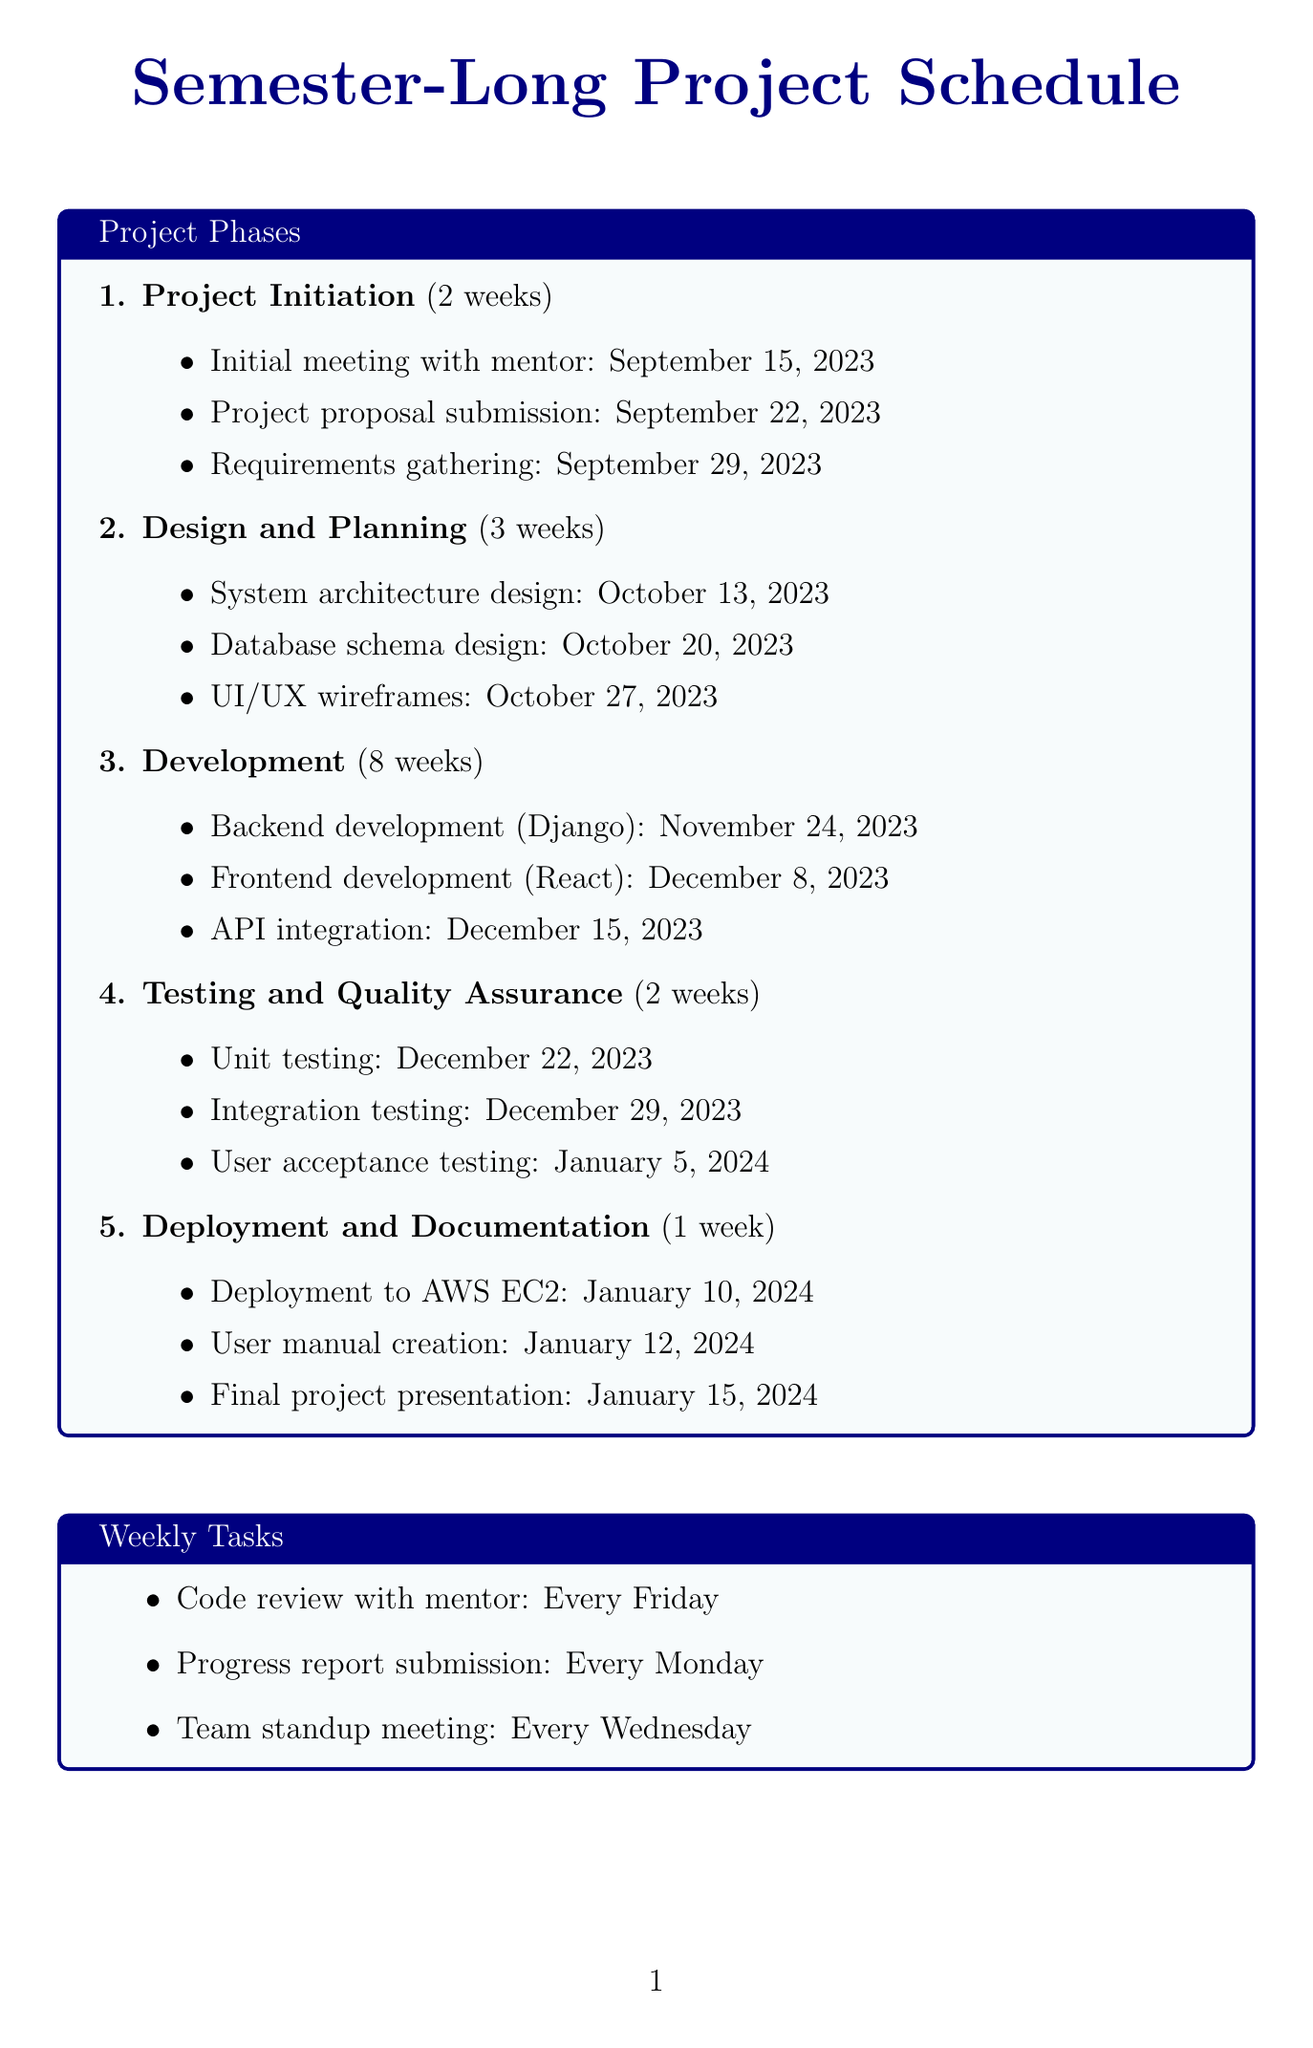What is the duration of the Project Initiation phase? The duration of the Project Initiation phase is specified in the document as 2 weeks.
Answer: 2 weeks What is the deadline for the UI/UX wireframes milestone? The deadline for the UI/UX wireframes milestone is listed as October 27, 2023.
Answer: October 27, 2023 Which development tool is used for version control? The document specifies that Git is used for version control among the development tools.
Answer: Git What is the deadline for the final project presentation? The deadline for the final project presentation is stated as January 15, 2024.
Answer: January 15, 2024 How many weeks is the Development phase scheduled for? The Development phase is scheduled for 8 weeks according to the document.
Answer: 8 weeks When do progress reports need to be submitted? Progress reports need to be submitted every Monday as per the weekly tasks outlined in the document.
Answer: Every Monday What is one of the learning objectives of the project? The document states several learning objectives; one of them is gaining hands-on experience with Agile development methodologies.
Answer: Gain hands-on experience with Agile development methodologies What type of testing occurs on January 5, 2024? The document indicates that user acceptance testing is scheduled for January 5, 2024.
Answer: User acceptance testing 